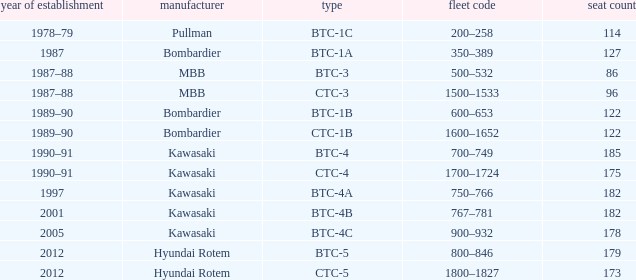For the train built in 2012 with less than 179 seats, what is the Fleet ID? 1800–1827. 